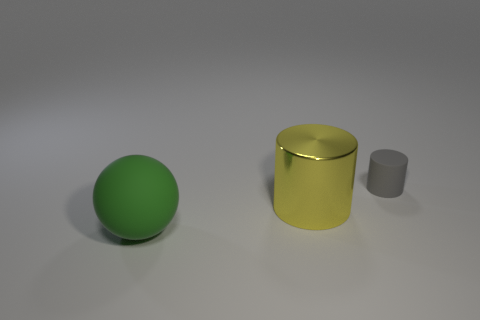Add 2 yellow cylinders. How many objects exist? 5 Subtract all spheres. How many objects are left? 2 Add 2 tiny gray rubber cylinders. How many tiny gray rubber cylinders exist? 3 Subtract 0 green cylinders. How many objects are left? 3 Subtract all gray rubber cubes. Subtract all big things. How many objects are left? 1 Add 1 gray matte cylinders. How many gray matte cylinders are left? 2 